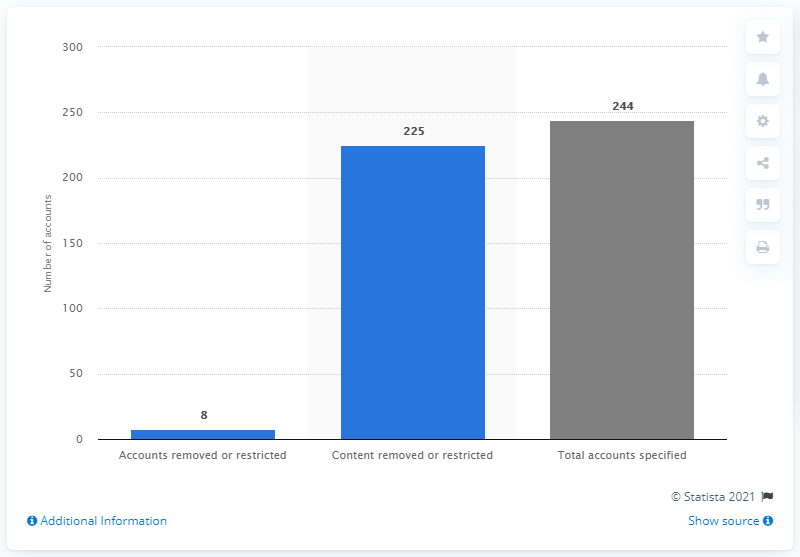List a handful of essential elements in this visual. The Indian government received 244 content removal requests between January and June 2020. During the period of January to June 2020, a total of 225 content links were removed or restricted by TikTok. 